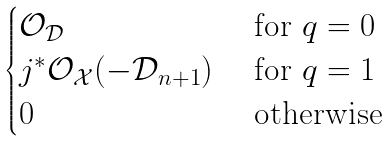Convert formula to latex. <formula><loc_0><loc_0><loc_500><loc_500>\begin{cases} \mathcal { O } _ { \mathcal { D } } & \text { for } q = 0 \\ j ^ { * } \mathcal { O } _ { \mathcal { X } } ( - \mathcal { D } _ { n + 1 } ) & \text { for } q = 1 \\ 0 & \text { otherwise} \end{cases}</formula> 